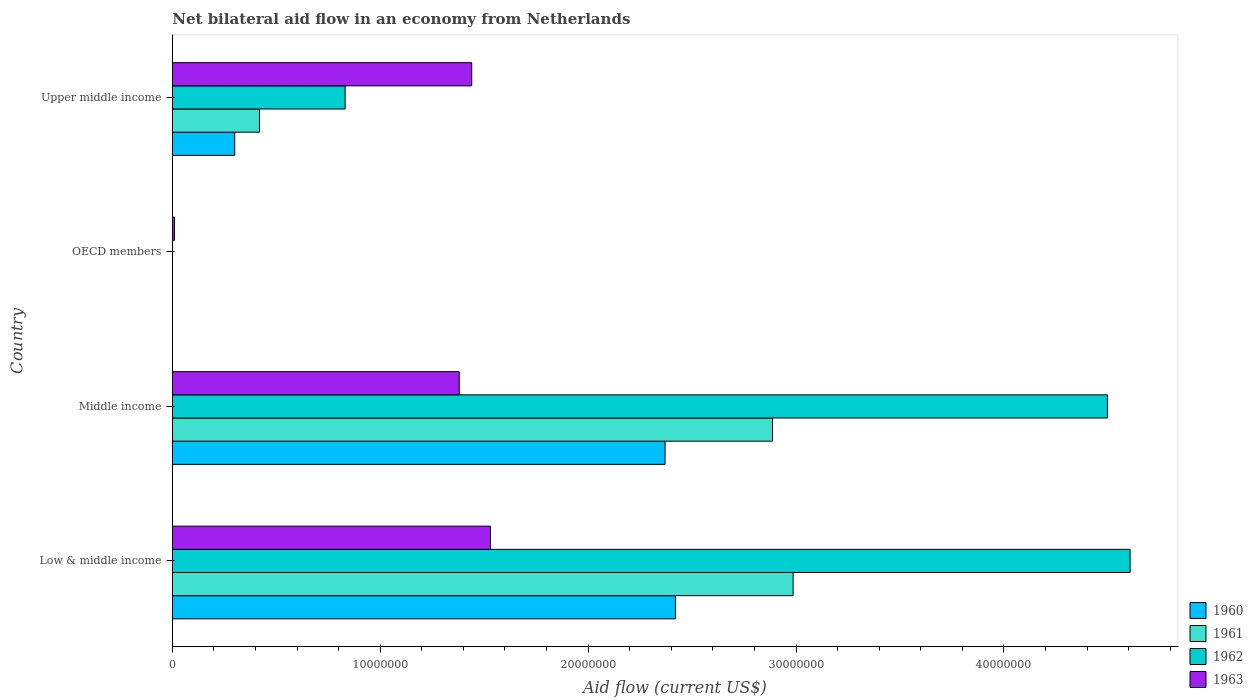Are the number of bars per tick equal to the number of legend labels?
Offer a very short reply. No. How many bars are there on the 1st tick from the top?
Make the answer very short. 4. What is the label of the 2nd group of bars from the top?
Provide a short and direct response. OECD members. In how many cases, is the number of bars for a given country not equal to the number of legend labels?
Ensure brevity in your answer.  1. Across all countries, what is the maximum net bilateral aid flow in 1960?
Keep it short and to the point. 2.42e+07. What is the total net bilateral aid flow in 1960 in the graph?
Give a very brief answer. 5.09e+07. What is the difference between the net bilateral aid flow in 1963 in Low & middle income and that in OECD members?
Offer a terse response. 1.52e+07. What is the difference between the net bilateral aid flow in 1961 in Middle income and the net bilateral aid flow in 1960 in Low & middle income?
Provide a succinct answer. 4.67e+06. What is the average net bilateral aid flow in 1963 per country?
Offer a very short reply. 1.09e+07. What is the difference between the net bilateral aid flow in 1963 and net bilateral aid flow in 1962 in Middle income?
Your response must be concise. -3.12e+07. In how many countries, is the net bilateral aid flow in 1962 greater than 26000000 US$?
Your answer should be very brief. 2. What is the ratio of the net bilateral aid flow in 1960 in Middle income to that in Upper middle income?
Provide a short and direct response. 7.9. Is the difference between the net bilateral aid flow in 1963 in Middle income and Upper middle income greater than the difference between the net bilateral aid flow in 1962 in Middle income and Upper middle income?
Keep it short and to the point. No. What is the difference between the highest and the second highest net bilateral aid flow in 1961?
Keep it short and to the point. 9.90e+05. What is the difference between the highest and the lowest net bilateral aid flow in 1963?
Your response must be concise. 1.52e+07. Is the sum of the net bilateral aid flow in 1963 in Middle income and OECD members greater than the maximum net bilateral aid flow in 1960 across all countries?
Your answer should be compact. No. How many countries are there in the graph?
Your answer should be compact. 4. What is the difference between two consecutive major ticks on the X-axis?
Keep it short and to the point. 1.00e+07. Are the values on the major ticks of X-axis written in scientific E-notation?
Give a very brief answer. No. Does the graph contain any zero values?
Offer a very short reply. Yes. How are the legend labels stacked?
Your response must be concise. Vertical. What is the title of the graph?
Your answer should be compact. Net bilateral aid flow in an economy from Netherlands. Does "1989" appear as one of the legend labels in the graph?
Offer a very short reply. No. What is the Aid flow (current US$) in 1960 in Low & middle income?
Offer a very short reply. 2.42e+07. What is the Aid flow (current US$) in 1961 in Low & middle income?
Ensure brevity in your answer.  2.99e+07. What is the Aid flow (current US$) of 1962 in Low & middle income?
Provide a succinct answer. 4.61e+07. What is the Aid flow (current US$) of 1963 in Low & middle income?
Ensure brevity in your answer.  1.53e+07. What is the Aid flow (current US$) of 1960 in Middle income?
Ensure brevity in your answer.  2.37e+07. What is the Aid flow (current US$) in 1961 in Middle income?
Ensure brevity in your answer.  2.89e+07. What is the Aid flow (current US$) of 1962 in Middle income?
Your response must be concise. 4.50e+07. What is the Aid flow (current US$) of 1963 in Middle income?
Keep it short and to the point. 1.38e+07. What is the Aid flow (current US$) in 1962 in OECD members?
Keep it short and to the point. 0. What is the Aid flow (current US$) of 1961 in Upper middle income?
Ensure brevity in your answer.  4.19e+06. What is the Aid flow (current US$) of 1962 in Upper middle income?
Offer a terse response. 8.31e+06. What is the Aid flow (current US$) of 1963 in Upper middle income?
Your answer should be very brief. 1.44e+07. Across all countries, what is the maximum Aid flow (current US$) in 1960?
Provide a short and direct response. 2.42e+07. Across all countries, what is the maximum Aid flow (current US$) in 1961?
Your response must be concise. 2.99e+07. Across all countries, what is the maximum Aid flow (current US$) of 1962?
Your answer should be very brief. 4.61e+07. Across all countries, what is the maximum Aid flow (current US$) of 1963?
Your answer should be compact. 1.53e+07. Across all countries, what is the minimum Aid flow (current US$) in 1962?
Provide a succinct answer. 0. Across all countries, what is the minimum Aid flow (current US$) in 1963?
Your answer should be compact. 1.00e+05. What is the total Aid flow (current US$) of 1960 in the graph?
Offer a terse response. 5.09e+07. What is the total Aid flow (current US$) in 1961 in the graph?
Provide a succinct answer. 6.29e+07. What is the total Aid flow (current US$) in 1962 in the graph?
Your answer should be very brief. 9.94e+07. What is the total Aid flow (current US$) of 1963 in the graph?
Keep it short and to the point. 4.36e+07. What is the difference between the Aid flow (current US$) of 1960 in Low & middle income and that in Middle income?
Provide a succinct answer. 5.00e+05. What is the difference between the Aid flow (current US$) in 1961 in Low & middle income and that in Middle income?
Give a very brief answer. 9.90e+05. What is the difference between the Aid flow (current US$) of 1962 in Low & middle income and that in Middle income?
Keep it short and to the point. 1.09e+06. What is the difference between the Aid flow (current US$) in 1963 in Low & middle income and that in Middle income?
Provide a succinct answer. 1.50e+06. What is the difference between the Aid flow (current US$) of 1963 in Low & middle income and that in OECD members?
Make the answer very short. 1.52e+07. What is the difference between the Aid flow (current US$) in 1960 in Low & middle income and that in Upper middle income?
Offer a terse response. 2.12e+07. What is the difference between the Aid flow (current US$) of 1961 in Low & middle income and that in Upper middle income?
Provide a short and direct response. 2.57e+07. What is the difference between the Aid flow (current US$) in 1962 in Low & middle income and that in Upper middle income?
Ensure brevity in your answer.  3.78e+07. What is the difference between the Aid flow (current US$) of 1963 in Middle income and that in OECD members?
Offer a very short reply. 1.37e+07. What is the difference between the Aid flow (current US$) in 1960 in Middle income and that in Upper middle income?
Your response must be concise. 2.07e+07. What is the difference between the Aid flow (current US$) in 1961 in Middle income and that in Upper middle income?
Ensure brevity in your answer.  2.47e+07. What is the difference between the Aid flow (current US$) in 1962 in Middle income and that in Upper middle income?
Ensure brevity in your answer.  3.67e+07. What is the difference between the Aid flow (current US$) of 1963 in Middle income and that in Upper middle income?
Your response must be concise. -6.00e+05. What is the difference between the Aid flow (current US$) of 1963 in OECD members and that in Upper middle income?
Provide a short and direct response. -1.43e+07. What is the difference between the Aid flow (current US$) in 1960 in Low & middle income and the Aid flow (current US$) in 1961 in Middle income?
Your answer should be compact. -4.67e+06. What is the difference between the Aid flow (current US$) in 1960 in Low & middle income and the Aid flow (current US$) in 1962 in Middle income?
Provide a short and direct response. -2.08e+07. What is the difference between the Aid flow (current US$) in 1960 in Low & middle income and the Aid flow (current US$) in 1963 in Middle income?
Provide a succinct answer. 1.04e+07. What is the difference between the Aid flow (current US$) of 1961 in Low & middle income and the Aid flow (current US$) of 1962 in Middle income?
Make the answer very short. -1.51e+07. What is the difference between the Aid flow (current US$) of 1961 in Low & middle income and the Aid flow (current US$) of 1963 in Middle income?
Provide a succinct answer. 1.61e+07. What is the difference between the Aid flow (current US$) in 1962 in Low & middle income and the Aid flow (current US$) in 1963 in Middle income?
Your response must be concise. 3.23e+07. What is the difference between the Aid flow (current US$) in 1960 in Low & middle income and the Aid flow (current US$) in 1963 in OECD members?
Keep it short and to the point. 2.41e+07. What is the difference between the Aid flow (current US$) of 1961 in Low & middle income and the Aid flow (current US$) of 1963 in OECD members?
Provide a succinct answer. 2.98e+07. What is the difference between the Aid flow (current US$) in 1962 in Low & middle income and the Aid flow (current US$) in 1963 in OECD members?
Your answer should be compact. 4.60e+07. What is the difference between the Aid flow (current US$) in 1960 in Low & middle income and the Aid flow (current US$) in 1961 in Upper middle income?
Ensure brevity in your answer.  2.00e+07. What is the difference between the Aid flow (current US$) in 1960 in Low & middle income and the Aid flow (current US$) in 1962 in Upper middle income?
Give a very brief answer. 1.59e+07. What is the difference between the Aid flow (current US$) in 1960 in Low & middle income and the Aid flow (current US$) in 1963 in Upper middle income?
Provide a succinct answer. 9.80e+06. What is the difference between the Aid flow (current US$) in 1961 in Low & middle income and the Aid flow (current US$) in 1962 in Upper middle income?
Make the answer very short. 2.16e+07. What is the difference between the Aid flow (current US$) of 1961 in Low & middle income and the Aid flow (current US$) of 1963 in Upper middle income?
Your answer should be very brief. 1.55e+07. What is the difference between the Aid flow (current US$) of 1962 in Low & middle income and the Aid flow (current US$) of 1963 in Upper middle income?
Offer a terse response. 3.17e+07. What is the difference between the Aid flow (current US$) in 1960 in Middle income and the Aid flow (current US$) in 1963 in OECD members?
Your answer should be compact. 2.36e+07. What is the difference between the Aid flow (current US$) of 1961 in Middle income and the Aid flow (current US$) of 1963 in OECD members?
Offer a very short reply. 2.88e+07. What is the difference between the Aid flow (current US$) of 1962 in Middle income and the Aid flow (current US$) of 1963 in OECD members?
Provide a short and direct response. 4.49e+07. What is the difference between the Aid flow (current US$) of 1960 in Middle income and the Aid flow (current US$) of 1961 in Upper middle income?
Offer a very short reply. 1.95e+07. What is the difference between the Aid flow (current US$) of 1960 in Middle income and the Aid flow (current US$) of 1962 in Upper middle income?
Your answer should be very brief. 1.54e+07. What is the difference between the Aid flow (current US$) of 1960 in Middle income and the Aid flow (current US$) of 1963 in Upper middle income?
Offer a terse response. 9.30e+06. What is the difference between the Aid flow (current US$) of 1961 in Middle income and the Aid flow (current US$) of 1962 in Upper middle income?
Offer a terse response. 2.06e+07. What is the difference between the Aid flow (current US$) in 1961 in Middle income and the Aid flow (current US$) in 1963 in Upper middle income?
Your answer should be compact. 1.45e+07. What is the difference between the Aid flow (current US$) in 1962 in Middle income and the Aid flow (current US$) in 1963 in Upper middle income?
Ensure brevity in your answer.  3.06e+07. What is the average Aid flow (current US$) in 1960 per country?
Offer a very short reply. 1.27e+07. What is the average Aid flow (current US$) of 1961 per country?
Your response must be concise. 1.57e+07. What is the average Aid flow (current US$) in 1962 per country?
Keep it short and to the point. 2.48e+07. What is the average Aid flow (current US$) in 1963 per country?
Your response must be concise. 1.09e+07. What is the difference between the Aid flow (current US$) of 1960 and Aid flow (current US$) of 1961 in Low & middle income?
Provide a succinct answer. -5.66e+06. What is the difference between the Aid flow (current US$) of 1960 and Aid flow (current US$) of 1962 in Low & middle income?
Provide a short and direct response. -2.19e+07. What is the difference between the Aid flow (current US$) in 1960 and Aid flow (current US$) in 1963 in Low & middle income?
Your response must be concise. 8.90e+06. What is the difference between the Aid flow (current US$) of 1961 and Aid flow (current US$) of 1962 in Low & middle income?
Provide a short and direct response. -1.62e+07. What is the difference between the Aid flow (current US$) of 1961 and Aid flow (current US$) of 1963 in Low & middle income?
Provide a succinct answer. 1.46e+07. What is the difference between the Aid flow (current US$) in 1962 and Aid flow (current US$) in 1963 in Low & middle income?
Your response must be concise. 3.08e+07. What is the difference between the Aid flow (current US$) in 1960 and Aid flow (current US$) in 1961 in Middle income?
Offer a terse response. -5.17e+06. What is the difference between the Aid flow (current US$) in 1960 and Aid flow (current US$) in 1962 in Middle income?
Ensure brevity in your answer.  -2.13e+07. What is the difference between the Aid flow (current US$) of 1960 and Aid flow (current US$) of 1963 in Middle income?
Your answer should be compact. 9.90e+06. What is the difference between the Aid flow (current US$) in 1961 and Aid flow (current US$) in 1962 in Middle income?
Your answer should be compact. -1.61e+07. What is the difference between the Aid flow (current US$) in 1961 and Aid flow (current US$) in 1963 in Middle income?
Give a very brief answer. 1.51e+07. What is the difference between the Aid flow (current US$) of 1962 and Aid flow (current US$) of 1963 in Middle income?
Provide a succinct answer. 3.12e+07. What is the difference between the Aid flow (current US$) in 1960 and Aid flow (current US$) in 1961 in Upper middle income?
Ensure brevity in your answer.  -1.19e+06. What is the difference between the Aid flow (current US$) of 1960 and Aid flow (current US$) of 1962 in Upper middle income?
Ensure brevity in your answer.  -5.31e+06. What is the difference between the Aid flow (current US$) of 1960 and Aid flow (current US$) of 1963 in Upper middle income?
Give a very brief answer. -1.14e+07. What is the difference between the Aid flow (current US$) in 1961 and Aid flow (current US$) in 1962 in Upper middle income?
Provide a short and direct response. -4.12e+06. What is the difference between the Aid flow (current US$) of 1961 and Aid flow (current US$) of 1963 in Upper middle income?
Your answer should be very brief. -1.02e+07. What is the difference between the Aid flow (current US$) in 1962 and Aid flow (current US$) in 1963 in Upper middle income?
Provide a short and direct response. -6.09e+06. What is the ratio of the Aid flow (current US$) in 1960 in Low & middle income to that in Middle income?
Offer a terse response. 1.02. What is the ratio of the Aid flow (current US$) in 1961 in Low & middle income to that in Middle income?
Your answer should be very brief. 1.03. What is the ratio of the Aid flow (current US$) of 1962 in Low & middle income to that in Middle income?
Your answer should be very brief. 1.02. What is the ratio of the Aid flow (current US$) in 1963 in Low & middle income to that in Middle income?
Keep it short and to the point. 1.11. What is the ratio of the Aid flow (current US$) in 1963 in Low & middle income to that in OECD members?
Ensure brevity in your answer.  153. What is the ratio of the Aid flow (current US$) of 1960 in Low & middle income to that in Upper middle income?
Your response must be concise. 8.07. What is the ratio of the Aid flow (current US$) in 1961 in Low & middle income to that in Upper middle income?
Make the answer very short. 7.13. What is the ratio of the Aid flow (current US$) of 1962 in Low & middle income to that in Upper middle income?
Offer a very short reply. 5.54. What is the ratio of the Aid flow (current US$) of 1963 in Low & middle income to that in Upper middle income?
Make the answer very short. 1.06. What is the ratio of the Aid flow (current US$) of 1963 in Middle income to that in OECD members?
Make the answer very short. 138. What is the ratio of the Aid flow (current US$) in 1961 in Middle income to that in Upper middle income?
Offer a very short reply. 6.89. What is the ratio of the Aid flow (current US$) of 1962 in Middle income to that in Upper middle income?
Offer a very short reply. 5.41. What is the ratio of the Aid flow (current US$) of 1963 in Middle income to that in Upper middle income?
Provide a succinct answer. 0.96. What is the ratio of the Aid flow (current US$) of 1963 in OECD members to that in Upper middle income?
Offer a very short reply. 0.01. What is the difference between the highest and the second highest Aid flow (current US$) of 1961?
Keep it short and to the point. 9.90e+05. What is the difference between the highest and the second highest Aid flow (current US$) in 1962?
Offer a terse response. 1.09e+06. What is the difference between the highest and the second highest Aid flow (current US$) of 1963?
Provide a short and direct response. 9.00e+05. What is the difference between the highest and the lowest Aid flow (current US$) in 1960?
Give a very brief answer. 2.42e+07. What is the difference between the highest and the lowest Aid flow (current US$) in 1961?
Provide a succinct answer. 2.99e+07. What is the difference between the highest and the lowest Aid flow (current US$) in 1962?
Offer a terse response. 4.61e+07. What is the difference between the highest and the lowest Aid flow (current US$) in 1963?
Your response must be concise. 1.52e+07. 